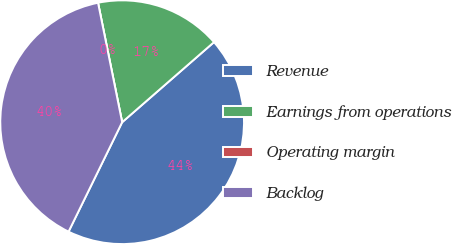Convert chart. <chart><loc_0><loc_0><loc_500><loc_500><pie_chart><fcel>Revenue<fcel>Earnings from operations<fcel>Operating margin<fcel>Backlog<nl><fcel>43.66%<fcel>16.76%<fcel>0.0%<fcel>39.58%<nl></chart> 